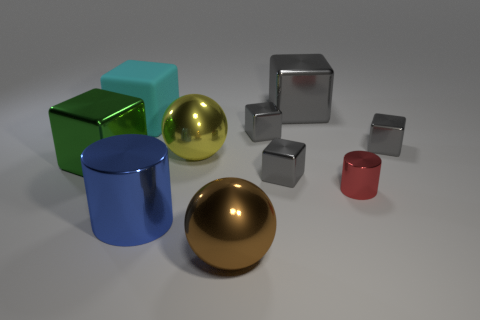Subtract all gray blocks. How many were subtracted if there are1gray blocks left? 3 Subtract all large shiny cubes. How many cubes are left? 4 Subtract all green blocks. How many blocks are left? 5 Subtract all spheres. How many objects are left? 8 Subtract all big yellow things. Subtract all tiny blue matte cylinders. How many objects are left? 9 Add 4 blue objects. How many blue objects are left? 5 Add 9 blue cylinders. How many blue cylinders exist? 10 Subtract 0 yellow cubes. How many objects are left? 10 Subtract 1 cylinders. How many cylinders are left? 1 Subtract all gray blocks. Subtract all blue cylinders. How many blocks are left? 2 